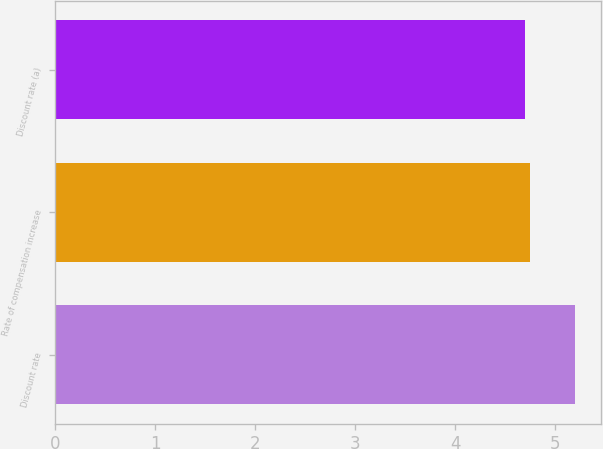Convert chart. <chart><loc_0><loc_0><loc_500><loc_500><bar_chart><fcel>Discount rate<fcel>Rate of compensation increase<fcel>Discount rate (a)<nl><fcel>5.2<fcel>4.75<fcel>4.7<nl></chart> 